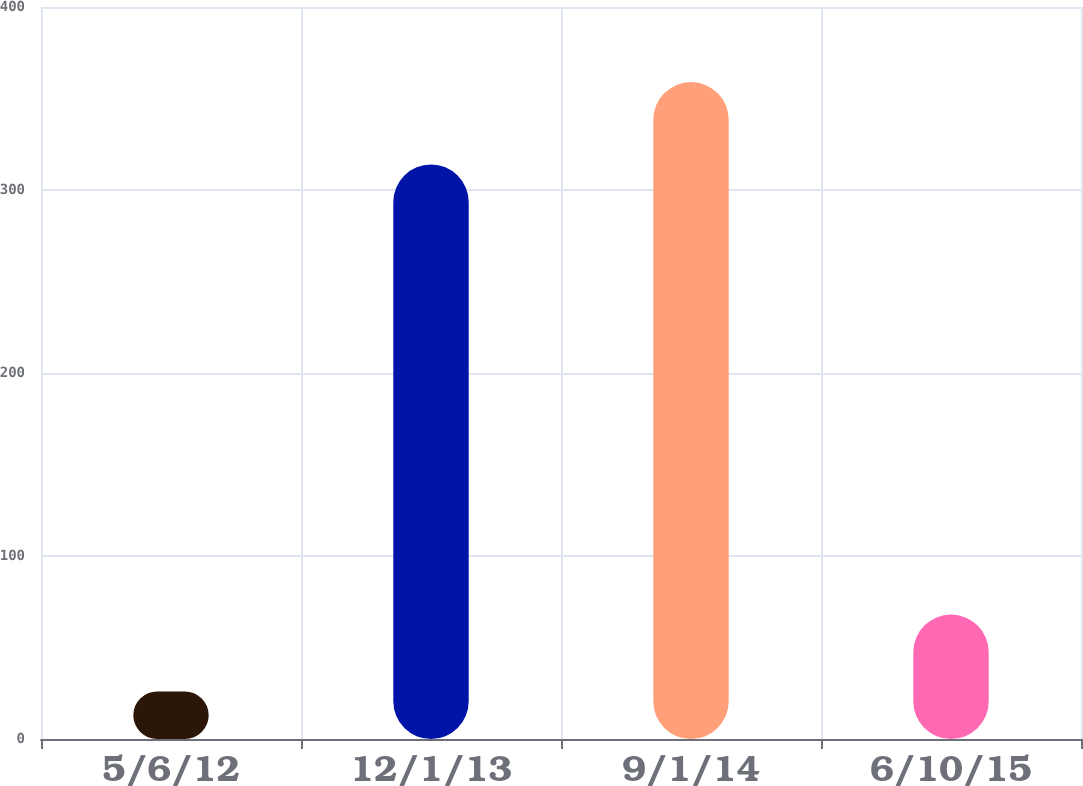Convert chart. <chart><loc_0><loc_0><loc_500><loc_500><bar_chart><fcel>5/6/12<fcel>12/1/13<fcel>9/1/14<fcel>6/10/15<nl><fcel>26<fcel>314<fcel>359<fcel>68<nl></chart> 